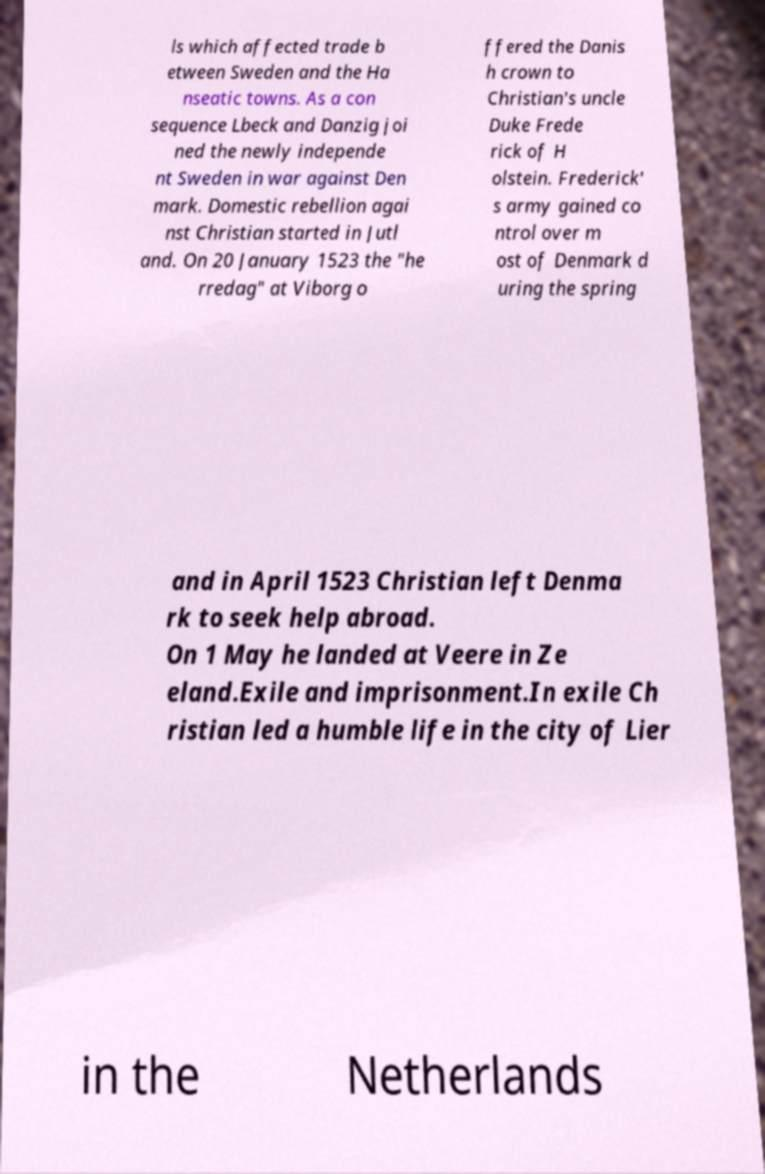Could you assist in decoding the text presented in this image and type it out clearly? ls which affected trade b etween Sweden and the Ha nseatic towns. As a con sequence Lbeck and Danzig joi ned the newly independe nt Sweden in war against Den mark. Domestic rebellion agai nst Christian started in Jutl and. On 20 January 1523 the "he rredag" at Viborg o ffered the Danis h crown to Christian's uncle Duke Frede rick of H olstein. Frederick' s army gained co ntrol over m ost of Denmark d uring the spring and in April 1523 Christian left Denma rk to seek help abroad. On 1 May he landed at Veere in Ze eland.Exile and imprisonment.In exile Ch ristian led a humble life in the city of Lier in the Netherlands 